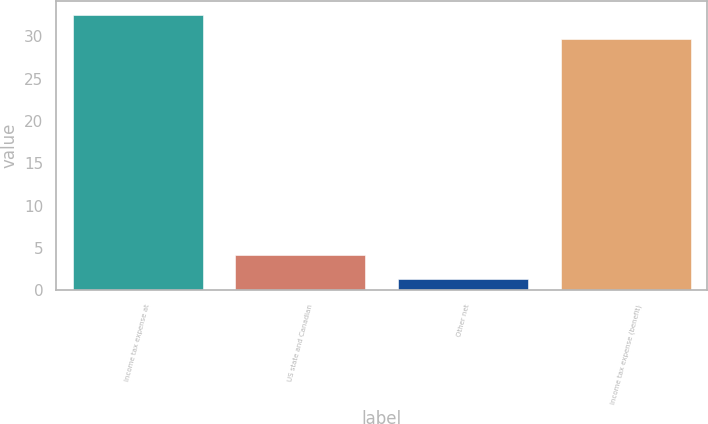Convert chart. <chart><loc_0><loc_0><loc_500><loc_500><bar_chart><fcel>Income tax expense at<fcel>US state and Canadian<fcel>Other net<fcel>Income tax expense (benefit)<nl><fcel>32.54<fcel>4.24<fcel>1.4<fcel>29.7<nl></chart> 